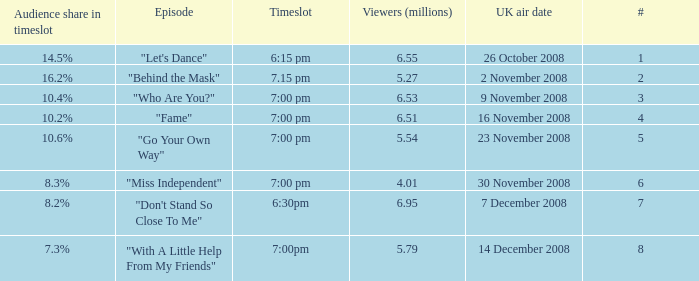Name the total number of viewers for audience share in timeslot for 10.2% 1.0. Parse the table in full. {'header': ['Audience share in timeslot', 'Episode', 'Timeslot', 'Viewers (millions)', 'UK air date', '#'], 'rows': [['14.5%', '"Let\'s Dance"', '6:15 pm', '6.55', '26 October 2008', '1'], ['16.2%', '"Behind the Mask"', '7.15 pm', '5.27', '2 November 2008', '2'], ['10.4%', '"Who Are You?"', '7:00 pm', '6.53', '9 November 2008', '3'], ['10.2%', '"Fame"', '7:00 pm', '6.51', '16 November 2008', '4'], ['10.6%', '"Go Your Own Way"', '7:00 pm', '5.54', '23 November 2008', '5'], ['8.3%', '"Miss Independent"', '7:00 pm', '4.01', '30 November 2008', '6'], ['8.2%', '"Don\'t Stand So Close To Me"', '6:30pm', '6.95', '7 December 2008', '7'], ['7.3%', '"With A Little Help From My Friends"', '7:00pm', '5.79', '14 December 2008', '8']]} 